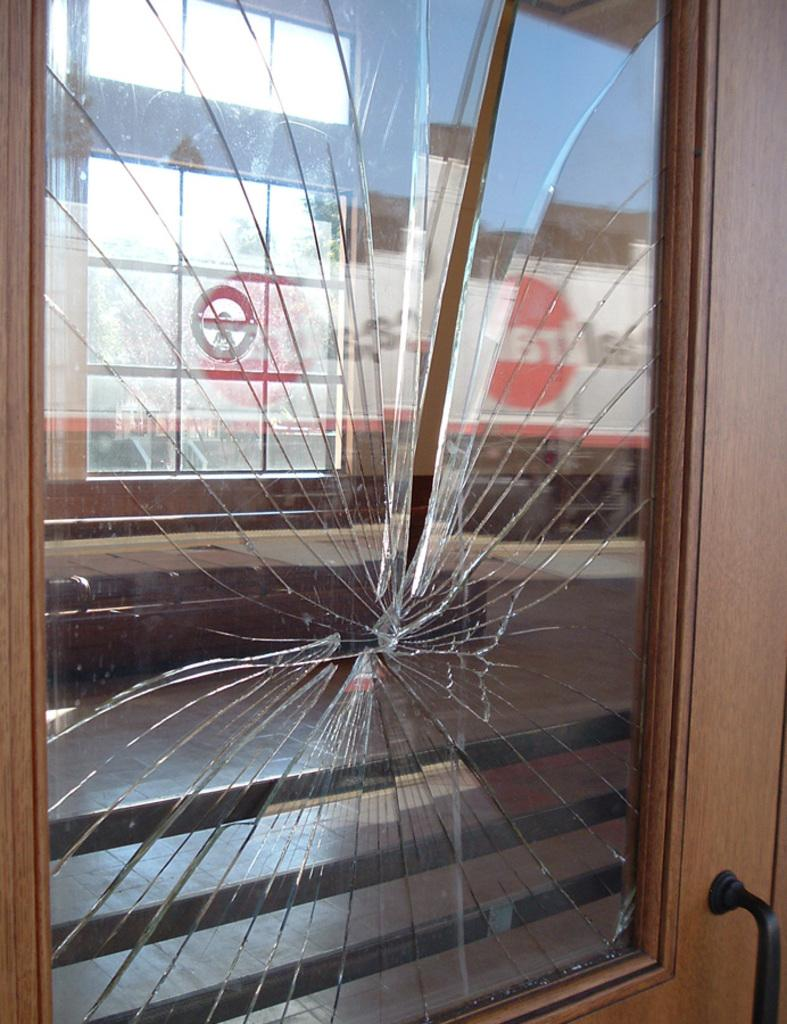What is the main subject in the foreground of the image? There is a broken glass of a door in the foreground of the image. What can be seen in the reflection of the broken glass? The reflection in the broken glass shows stairs and a glass window. What part of the natural environment is visible in the reflection of the broken glass? The sky is visible in the reflection of the broken glass. Can you tell me how many cats are sitting on the stairs in the image? There are no cats present in the image; the reflection in the broken glass shows stairs, but no cats are visible. 